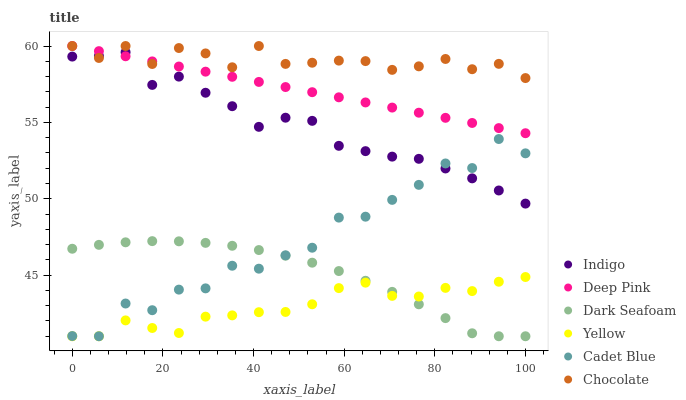Does Yellow have the minimum area under the curve?
Answer yes or no. Yes. Does Chocolate have the maximum area under the curve?
Answer yes or no. Yes. Does Indigo have the minimum area under the curve?
Answer yes or no. No. Does Indigo have the maximum area under the curve?
Answer yes or no. No. Is Deep Pink the smoothest?
Answer yes or no. Yes. Is Cadet Blue the roughest?
Answer yes or no. Yes. Is Indigo the smoothest?
Answer yes or no. No. Is Indigo the roughest?
Answer yes or no. No. Does Cadet Blue have the lowest value?
Answer yes or no. Yes. Does Indigo have the lowest value?
Answer yes or no. No. Does Deep Pink have the highest value?
Answer yes or no. Yes. Does Indigo have the highest value?
Answer yes or no. No. Is Dark Seafoam less than Indigo?
Answer yes or no. Yes. Is Indigo greater than Yellow?
Answer yes or no. Yes. Does Indigo intersect Chocolate?
Answer yes or no. Yes. Is Indigo less than Chocolate?
Answer yes or no. No. Is Indigo greater than Chocolate?
Answer yes or no. No. Does Dark Seafoam intersect Indigo?
Answer yes or no. No. 